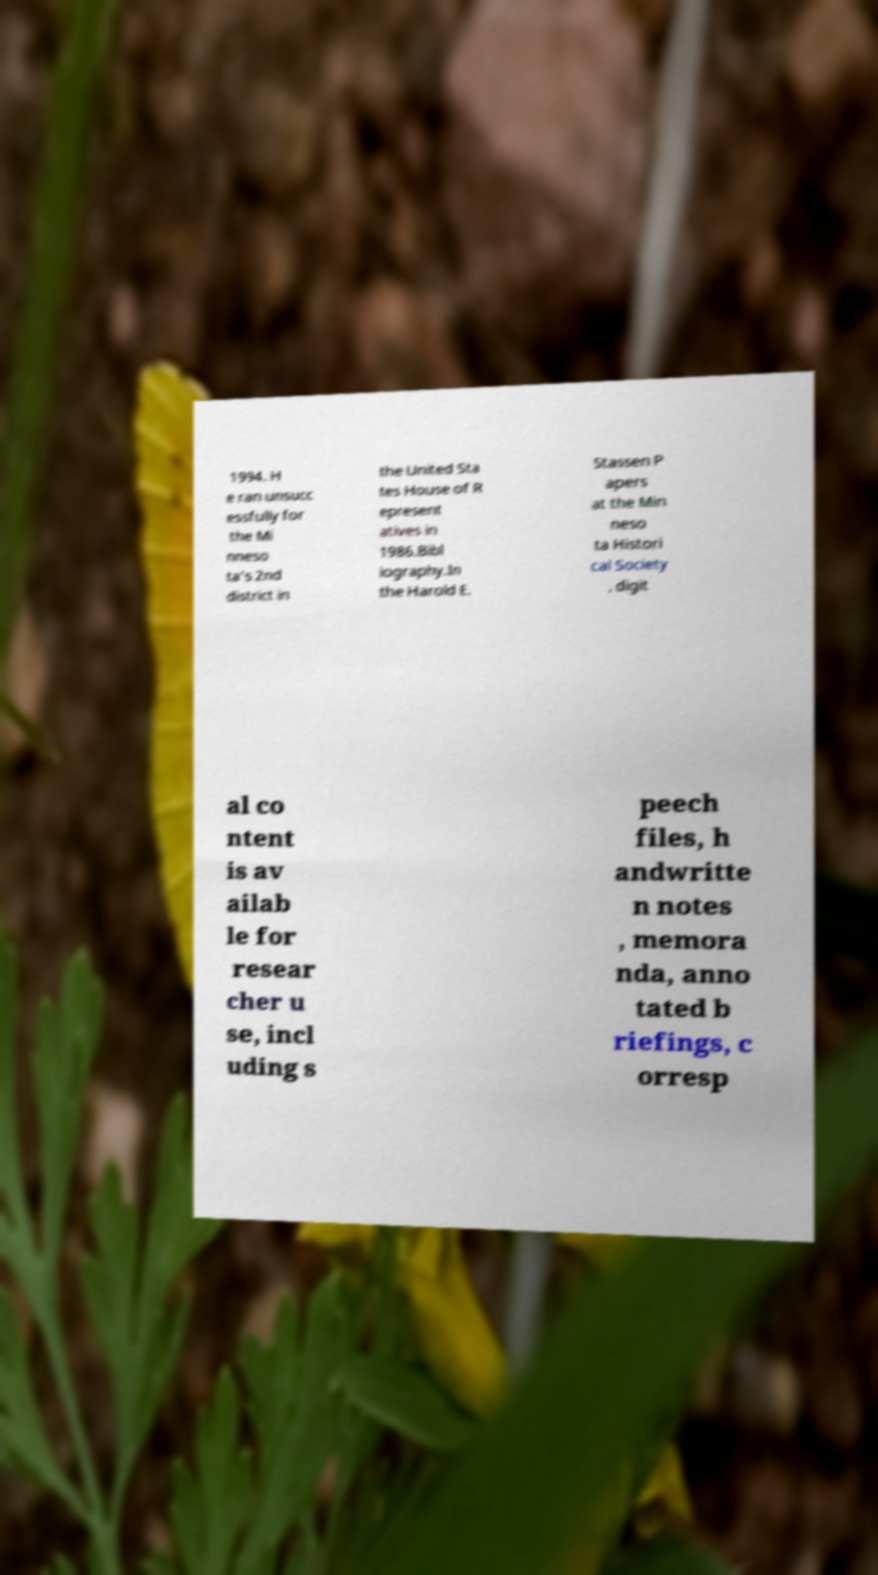Could you assist in decoding the text presented in this image and type it out clearly? 1994. H e ran unsucc essfully for the Mi nneso ta's 2nd district in the United Sta tes House of R epresent atives in 1986.Bibl iography.In the Harold E. Stassen P apers at the Min neso ta Histori cal Society , digit al co ntent is av ailab le for resear cher u se, incl uding s peech files, h andwritte n notes , memora nda, anno tated b riefings, c orresp 